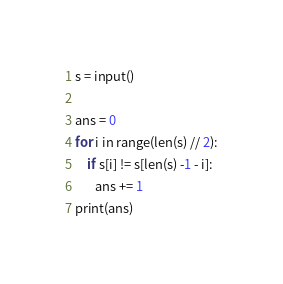<code> <loc_0><loc_0><loc_500><loc_500><_Python_>s = input()

ans = 0
for i in range(len(s) // 2):
    if s[i] != s[len(s) -1 - i]:
       ans += 1
print(ans)
</code> 